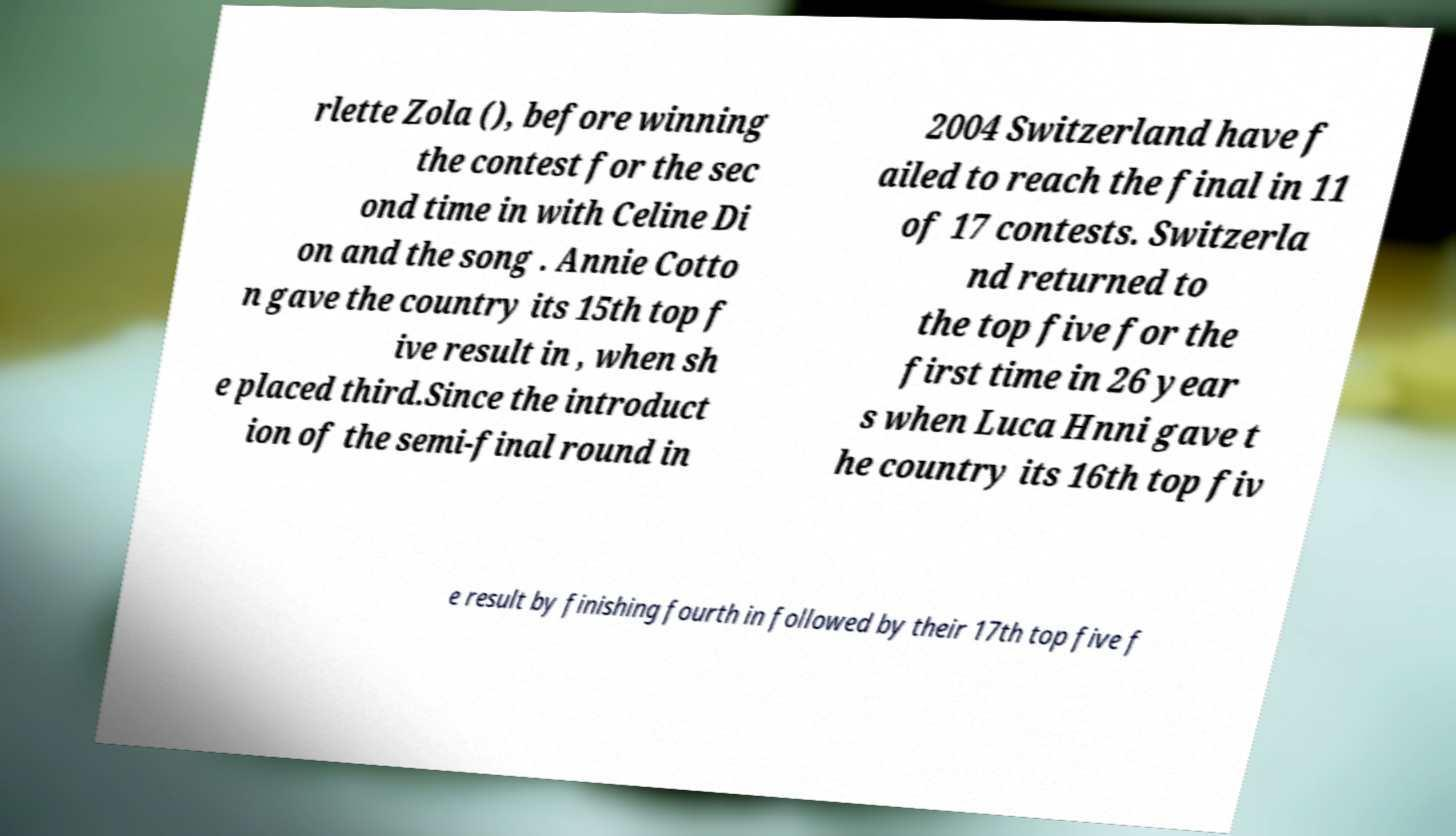I need the written content from this picture converted into text. Can you do that? rlette Zola (), before winning the contest for the sec ond time in with Celine Di on and the song . Annie Cotto n gave the country its 15th top f ive result in , when sh e placed third.Since the introduct ion of the semi-final round in 2004 Switzerland have f ailed to reach the final in 11 of 17 contests. Switzerla nd returned to the top five for the first time in 26 year s when Luca Hnni gave t he country its 16th top fiv e result by finishing fourth in followed by their 17th top five f 